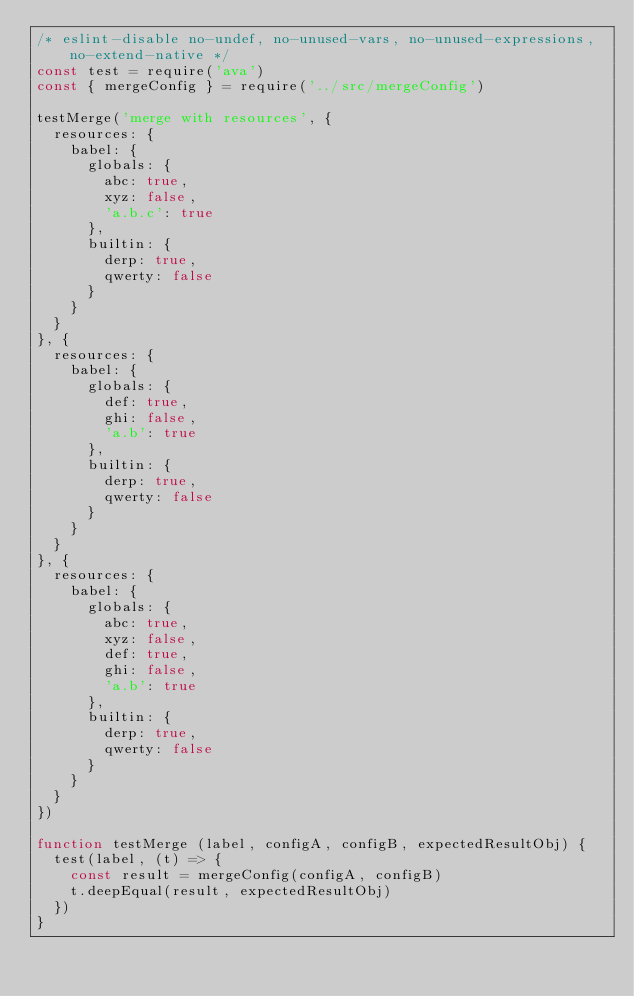Convert code to text. <code><loc_0><loc_0><loc_500><loc_500><_JavaScript_>/* eslint-disable no-undef, no-unused-vars, no-unused-expressions, no-extend-native */
const test = require('ava')
const { mergeConfig } = require('../src/mergeConfig')

testMerge('merge with resources', {
  resources: {
    babel: {
      globals: {
        abc: true,
        xyz: false,
        'a.b.c': true
      },
      builtin: {
        derp: true,
        qwerty: false
      }
    }
  }
}, {
  resources: {
    babel: {
      globals: {
        def: true,
        ghi: false,
        'a.b': true
      },
      builtin: {
        derp: true,
        qwerty: false
      }
    }
  }
}, {
  resources: {
    babel: {
      globals: {
        abc: true,
        xyz: false,
        def: true,
        ghi: false,
        'a.b': true
      },
      builtin: {
        derp: true,
        qwerty: false
      }
    }
  }
})

function testMerge (label, configA, configB, expectedResultObj) {
  test(label, (t) => {
    const result = mergeConfig(configA, configB)
    t.deepEqual(result, expectedResultObj)
  })
}
</code> 